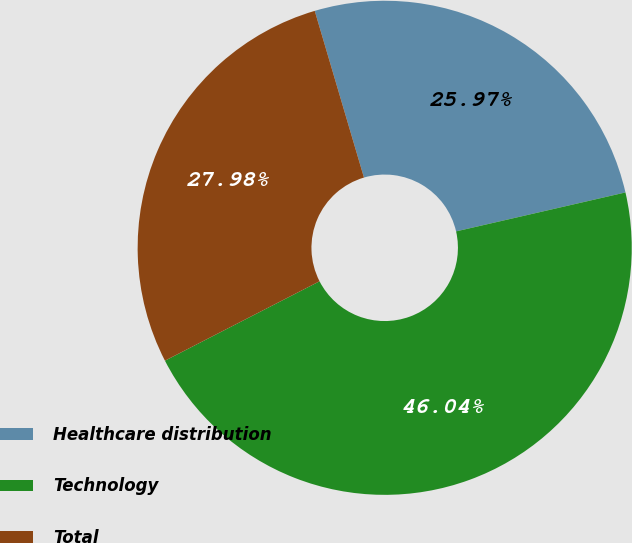Convert chart to OTSL. <chart><loc_0><loc_0><loc_500><loc_500><pie_chart><fcel>Healthcare distribution<fcel>Technology<fcel>Total<nl><fcel>25.97%<fcel>46.04%<fcel>27.98%<nl></chart> 